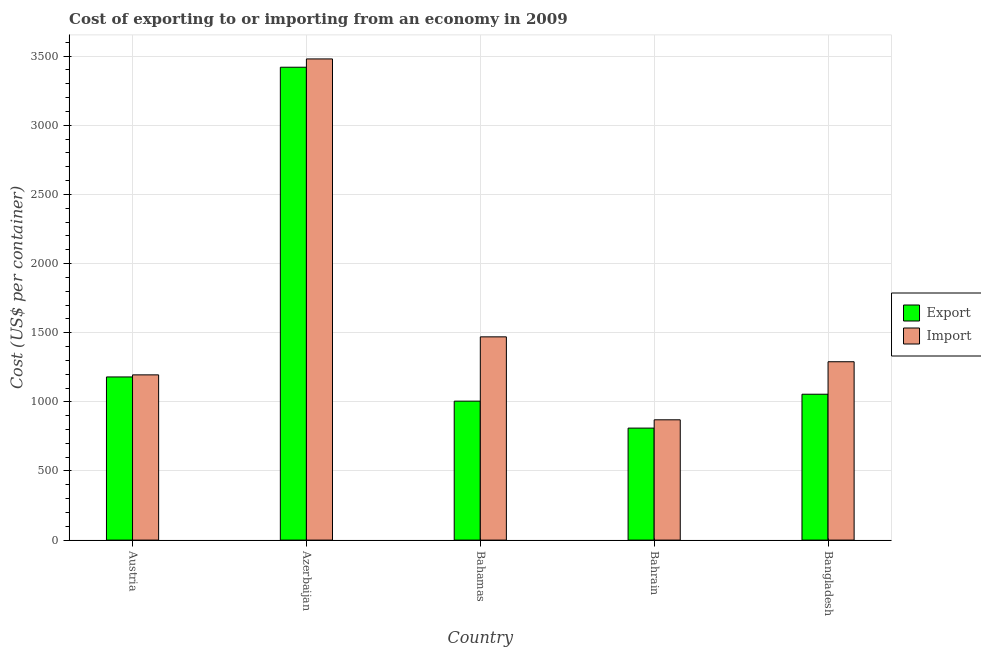How many different coloured bars are there?
Provide a succinct answer. 2. How many groups of bars are there?
Your answer should be compact. 5. Are the number of bars per tick equal to the number of legend labels?
Give a very brief answer. Yes. Are the number of bars on each tick of the X-axis equal?
Your answer should be compact. Yes. How many bars are there on the 3rd tick from the right?
Your answer should be very brief. 2. What is the label of the 2nd group of bars from the left?
Ensure brevity in your answer.  Azerbaijan. What is the export cost in Bahamas?
Your response must be concise. 1005. Across all countries, what is the maximum import cost?
Offer a terse response. 3480. Across all countries, what is the minimum export cost?
Keep it short and to the point. 810. In which country was the import cost maximum?
Make the answer very short. Azerbaijan. In which country was the export cost minimum?
Ensure brevity in your answer.  Bahrain. What is the total export cost in the graph?
Your response must be concise. 7470. What is the difference between the export cost in Azerbaijan and that in Bangladesh?
Your response must be concise. 2365. What is the difference between the import cost in Azerbaijan and the export cost in Austria?
Provide a succinct answer. 2300. What is the average export cost per country?
Offer a terse response. 1494. What is the difference between the import cost and export cost in Bahamas?
Provide a succinct answer. 465. In how many countries, is the export cost greater than 1600 US$?
Give a very brief answer. 1. What is the ratio of the export cost in Azerbaijan to that in Bangladesh?
Your answer should be compact. 3.24. Is the difference between the export cost in Bahrain and Bangladesh greater than the difference between the import cost in Bahrain and Bangladesh?
Your answer should be compact. Yes. What is the difference between the highest and the second highest export cost?
Offer a very short reply. 2240. What is the difference between the highest and the lowest export cost?
Provide a short and direct response. 2610. In how many countries, is the import cost greater than the average import cost taken over all countries?
Provide a short and direct response. 1. Is the sum of the export cost in Azerbaijan and Bahamas greater than the maximum import cost across all countries?
Offer a very short reply. Yes. What does the 2nd bar from the left in Bahrain represents?
Offer a terse response. Import. What does the 2nd bar from the right in Azerbaijan represents?
Give a very brief answer. Export. How many countries are there in the graph?
Your response must be concise. 5. Are the values on the major ticks of Y-axis written in scientific E-notation?
Make the answer very short. No. How many legend labels are there?
Provide a short and direct response. 2. What is the title of the graph?
Your answer should be very brief. Cost of exporting to or importing from an economy in 2009. What is the label or title of the X-axis?
Offer a terse response. Country. What is the label or title of the Y-axis?
Provide a succinct answer. Cost (US$ per container). What is the Cost (US$ per container) of Export in Austria?
Provide a short and direct response. 1180. What is the Cost (US$ per container) of Import in Austria?
Your answer should be very brief. 1195. What is the Cost (US$ per container) in Export in Azerbaijan?
Keep it short and to the point. 3420. What is the Cost (US$ per container) in Import in Azerbaijan?
Make the answer very short. 3480. What is the Cost (US$ per container) in Export in Bahamas?
Your answer should be very brief. 1005. What is the Cost (US$ per container) in Import in Bahamas?
Give a very brief answer. 1470. What is the Cost (US$ per container) of Export in Bahrain?
Give a very brief answer. 810. What is the Cost (US$ per container) of Import in Bahrain?
Your response must be concise. 870. What is the Cost (US$ per container) in Export in Bangladesh?
Give a very brief answer. 1055. What is the Cost (US$ per container) of Import in Bangladesh?
Make the answer very short. 1290. Across all countries, what is the maximum Cost (US$ per container) of Export?
Provide a short and direct response. 3420. Across all countries, what is the maximum Cost (US$ per container) of Import?
Your answer should be compact. 3480. Across all countries, what is the minimum Cost (US$ per container) in Export?
Your response must be concise. 810. Across all countries, what is the minimum Cost (US$ per container) of Import?
Offer a terse response. 870. What is the total Cost (US$ per container) in Export in the graph?
Give a very brief answer. 7470. What is the total Cost (US$ per container) in Import in the graph?
Ensure brevity in your answer.  8305. What is the difference between the Cost (US$ per container) of Export in Austria and that in Azerbaijan?
Ensure brevity in your answer.  -2240. What is the difference between the Cost (US$ per container) in Import in Austria and that in Azerbaijan?
Ensure brevity in your answer.  -2285. What is the difference between the Cost (US$ per container) in Export in Austria and that in Bahamas?
Provide a short and direct response. 175. What is the difference between the Cost (US$ per container) of Import in Austria and that in Bahamas?
Provide a succinct answer. -275. What is the difference between the Cost (US$ per container) of Export in Austria and that in Bahrain?
Your response must be concise. 370. What is the difference between the Cost (US$ per container) in Import in Austria and that in Bahrain?
Give a very brief answer. 325. What is the difference between the Cost (US$ per container) in Export in Austria and that in Bangladesh?
Ensure brevity in your answer.  125. What is the difference between the Cost (US$ per container) of Import in Austria and that in Bangladesh?
Your answer should be compact. -95. What is the difference between the Cost (US$ per container) of Export in Azerbaijan and that in Bahamas?
Provide a short and direct response. 2415. What is the difference between the Cost (US$ per container) in Import in Azerbaijan and that in Bahamas?
Provide a short and direct response. 2010. What is the difference between the Cost (US$ per container) of Export in Azerbaijan and that in Bahrain?
Provide a short and direct response. 2610. What is the difference between the Cost (US$ per container) of Import in Azerbaijan and that in Bahrain?
Give a very brief answer. 2610. What is the difference between the Cost (US$ per container) of Export in Azerbaijan and that in Bangladesh?
Your answer should be compact. 2365. What is the difference between the Cost (US$ per container) in Import in Azerbaijan and that in Bangladesh?
Ensure brevity in your answer.  2190. What is the difference between the Cost (US$ per container) in Export in Bahamas and that in Bahrain?
Offer a terse response. 195. What is the difference between the Cost (US$ per container) of Import in Bahamas and that in Bahrain?
Offer a very short reply. 600. What is the difference between the Cost (US$ per container) of Import in Bahamas and that in Bangladesh?
Your answer should be compact. 180. What is the difference between the Cost (US$ per container) in Export in Bahrain and that in Bangladesh?
Offer a very short reply. -245. What is the difference between the Cost (US$ per container) of Import in Bahrain and that in Bangladesh?
Offer a very short reply. -420. What is the difference between the Cost (US$ per container) of Export in Austria and the Cost (US$ per container) of Import in Azerbaijan?
Your answer should be very brief. -2300. What is the difference between the Cost (US$ per container) in Export in Austria and the Cost (US$ per container) in Import in Bahamas?
Your response must be concise. -290. What is the difference between the Cost (US$ per container) in Export in Austria and the Cost (US$ per container) in Import in Bahrain?
Your response must be concise. 310. What is the difference between the Cost (US$ per container) of Export in Austria and the Cost (US$ per container) of Import in Bangladesh?
Your response must be concise. -110. What is the difference between the Cost (US$ per container) of Export in Azerbaijan and the Cost (US$ per container) of Import in Bahamas?
Offer a terse response. 1950. What is the difference between the Cost (US$ per container) in Export in Azerbaijan and the Cost (US$ per container) in Import in Bahrain?
Your answer should be very brief. 2550. What is the difference between the Cost (US$ per container) in Export in Azerbaijan and the Cost (US$ per container) in Import in Bangladesh?
Your response must be concise. 2130. What is the difference between the Cost (US$ per container) in Export in Bahamas and the Cost (US$ per container) in Import in Bahrain?
Offer a very short reply. 135. What is the difference between the Cost (US$ per container) of Export in Bahamas and the Cost (US$ per container) of Import in Bangladesh?
Offer a terse response. -285. What is the difference between the Cost (US$ per container) of Export in Bahrain and the Cost (US$ per container) of Import in Bangladesh?
Keep it short and to the point. -480. What is the average Cost (US$ per container) in Export per country?
Provide a succinct answer. 1494. What is the average Cost (US$ per container) in Import per country?
Provide a succinct answer. 1661. What is the difference between the Cost (US$ per container) in Export and Cost (US$ per container) in Import in Austria?
Offer a terse response. -15. What is the difference between the Cost (US$ per container) in Export and Cost (US$ per container) in Import in Azerbaijan?
Your response must be concise. -60. What is the difference between the Cost (US$ per container) of Export and Cost (US$ per container) of Import in Bahamas?
Make the answer very short. -465. What is the difference between the Cost (US$ per container) of Export and Cost (US$ per container) of Import in Bahrain?
Offer a terse response. -60. What is the difference between the Cost (US$ per container) in Export and Cost (US$ per container) in Import in Bangladesh?
Your answer should be very brief. -235. What is the ratio of the Cost (US$ per container) of Export in Austria to that in Azerbaijan?
Provide a short and direct response. 0.34. What is the ratio of the Cost (US$ per container) of Import in Austria to that in Azerbaijan?
Offer a very short reply. 0.34. What is the ratio of the Cost (US$ per container) of Export in Austria to that in Bahamas?
Your response must be concise. 1.17. What is the ratio of the Cost (US$ per container) in Import in Austria to that in Bahamas?
Your response must be concise. 0.81. What is the ratio of the Cost (US$ per container) in Export in Austria to that in Bahrain?
Ensure brevity in your answer.  1.46. What is the ratio of the Cost (US$ per container) of Import in Austria to that in Bahrain?
Your answer should be very brief. 1.37. What is the ratio of the Cost (US$ per container) in Export in Austria to that in Bangladesh?
Offer a terse response. 1.12. What is the ratio of the Cost (US$ per container) in Import in Austria to that in Bangladesh?
Offer a terse response. 0.93. What is the ratio of the Cost (US$ per container) of Export in Azerbaijan to that in Bahamas?
Your response must be concise. 3.4. What is the ratio of the Cost (US$ per container) of Import in Azerbaijan to that in Bahamas?
Provide a short and direct response. 2.37. What is the ratio of the Cost (US$ per container) in Export in Azerbaijan to that in Bahrain?
Your answer should be very brief. 4.22. What is the ratio of the Cost (US$ per container) in Import in Azerbaijan to that in Bahrain?
Your response must be concise. 4. What is the ratio of the Cost (US$ per container) of Export in Azerbaijan to that in Bangladesh?
Offer a terse response. 3.24. What is the ratio of the Cost (US$ per container) of Import in Azerbaijan to that in Bangladesh?
Make the answer very short. 2.7. What is the ratio of the Cost (US$ per container) in Export in Bahamas to that in Bahrain?
Your answer should be very brief. 1.24. What is the ratio of the Cost (US$ per container) of Import in Bahamas to that in Bahrain?
Provide a succinct answer. 1.69. What is the ratio of the Cost (US$ per container) of Export in Bahamas to that in Bangladesh?
Your answer should be compact. 0.95. What is the ratio of the Cost (US$ per container) of Import in Bahamas to that in Bangladesh?
Offer a very short reply. 1.14. What is the ratio of the Cost (US$ per container) of Export in Bahrain to that in Bangladesh?
Offer a terse response. 0.77. What is the ratio of the Cost (US$ per container) in Import in Bahrain to that in Bangladesh?
Your answer should be compact. 0.67. What is the difference between the highest and the second highest Cost (US$ per container) in Export?
Your response must be concise. 2240. What is the difference between the highest and the second highest Cost (US$ per container) in Import?
Make the answer very short. 2010. What is the difference between the highest and the lowest Cost (US$ per container) of Export?
Your answer should be very brief. 2610. What is the difference between the highest and the lowest Cost (US$ per container) of Import?
Provide a succinct answer. 2610. 